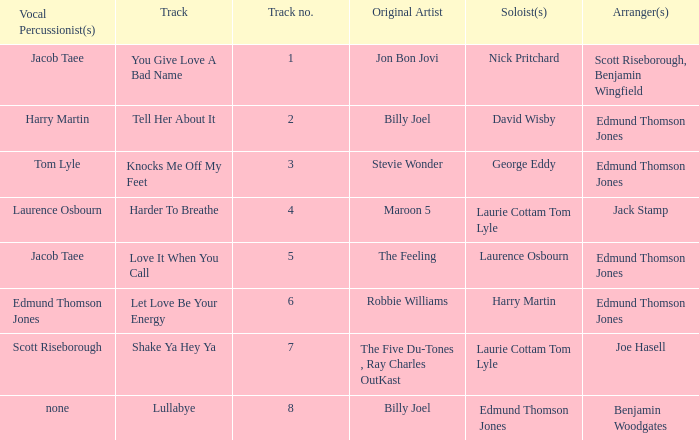Who were the original artist(s) for track number 6? Robbie Williams. 